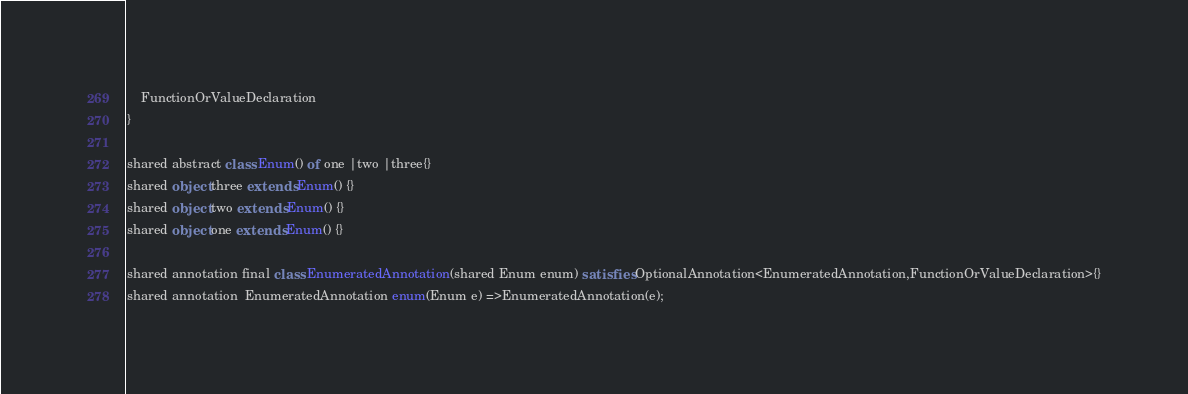Convert code to text. <code><loc_0><loc_0><loc_500><loc_500><_Ceylon_>	FunctionOrValueDeclaration
}

shared abstract class Enum() of one |two |three{}
shared object three extends Enum() {}
shared object two extends Enum() {}
shared object one extends Enum() {}

shared annotation final class EnumeratedAnnotation(shared Enum enum) satisfies OptionalAnnotation<EnumeratedAnnotation,FunctionOrValueDeclaration>{}
shared annotation  EnumeratedAnnotation enum(Enum e) =>EnumeratedAnnotation(e);</code> 